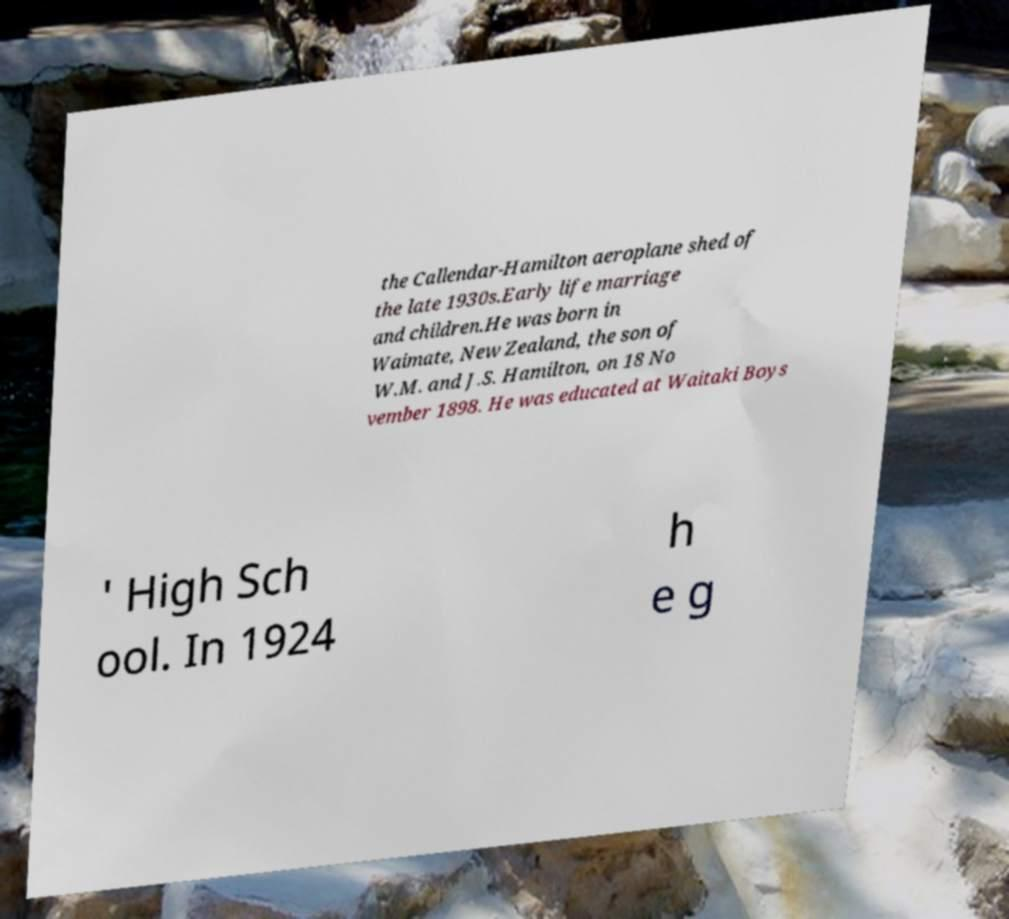For documentation purposes, I need the text within this image transcribed. Could you provide that? the Callendar-Hamilton aeroplane shed of the late 1930s.Early life marriage and children.He was born in Waimate, New Zealand, the son of W.M. and J.S. Hamilton, on 18 No vember 1898. He was educated at Waitaki Boys ' High Sch ool. In 1924 h e g 